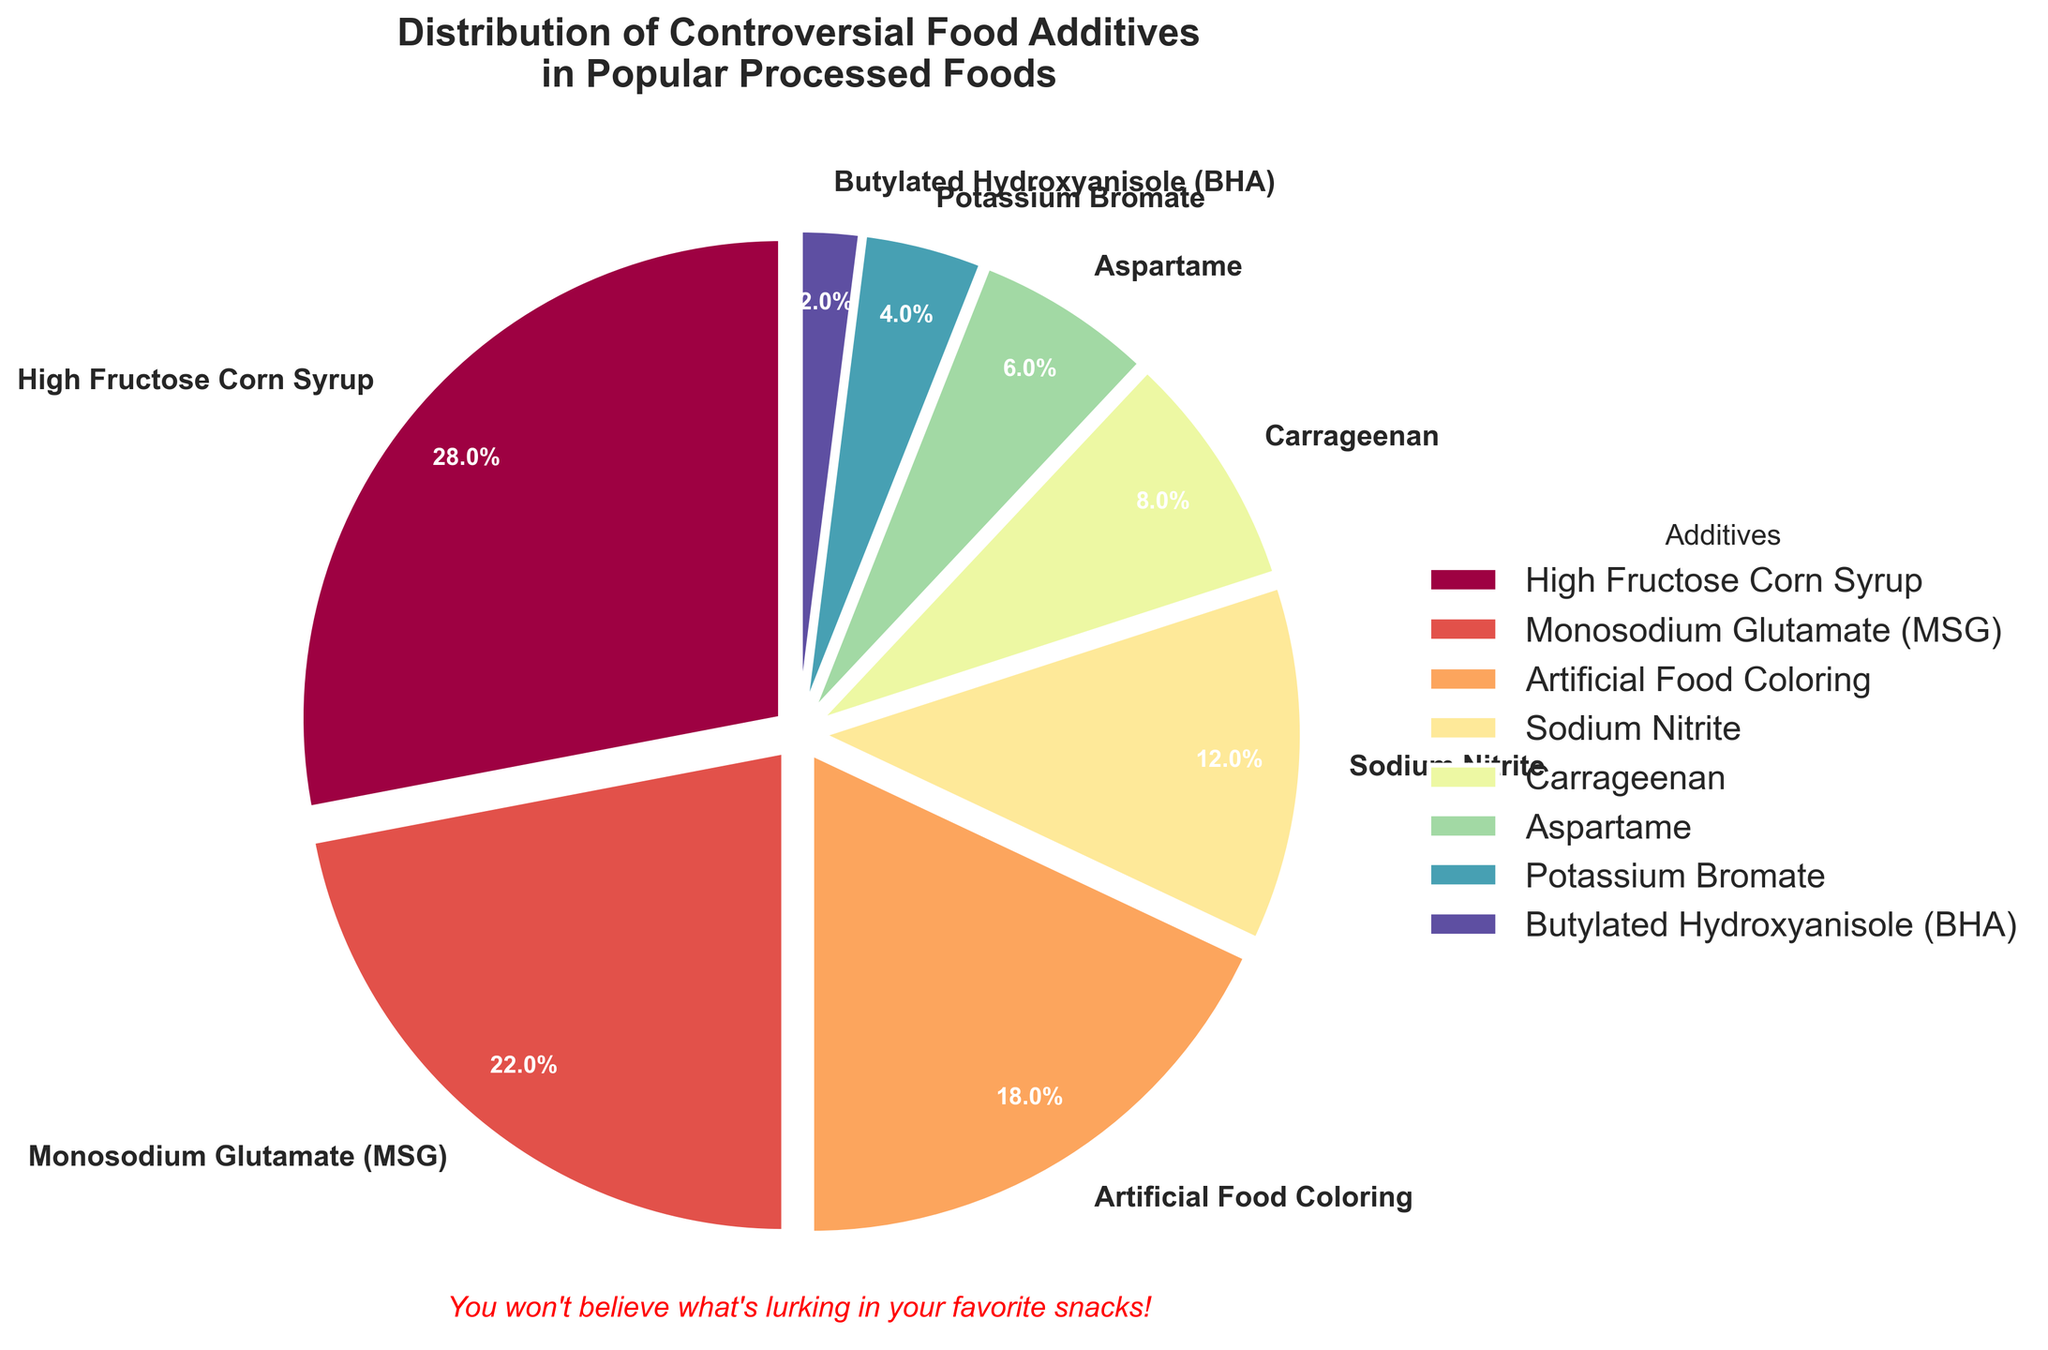What's the largest slice in the pie chart? The largest slice in the pie chart is labeled "High Fructose Corn Syrup" with a percentage of 28%. This can be seen visually by comparing the sizes of the slices.
Answer: High Fructose Corn Syrup Which two additives have the smallest percentages? The two additives with the smallest percentages are "Butylated Hydroxyanisole (BHA)" at 2% and "Potassium Bromate" at 4%. This is determined by identifying the smallest slices in the chart and reading the labels and percentages.
Answer: Butylated Hydroxyanisole (BHA) and Potassium Bromate What is the combined percentage of "Monosodium Glutamate (MSG)" and "Artificial Food Coloring"? To find the combined percentage of "Monosodium Glutamate (MSG)" and "Artificial Food Coloring," we add their percentages: 22% + 18% = 40%.
Answer: 40% How does the percentage of "Sodium Nitrite" compare to "Carrageenan"? "Sodium Nitrite" has a percentage of 12%, while "Carrageenan" has a percentage of 8%. By comparing these values, we see that "Sodium Nitrite" has a higher percentage than "Carrageenan."
Answer: Sodium Nitrite is greater What are the colors used for the slices representing "Aspartame" and "Potassium Bromate"? The pie chart uses a color gradient. "Aspartame" is marked with a color between yellow and orange, while "Potassium Bromate" is between light green and teal. This is observed by looking at the specific shades in the chart for these labels.
Answer: Aspartame: yellow-orange, Potassium Bromate: light green-teal 